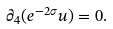Convert formula to latex. <formula><loc_0><loc_0><loc_500><loc_500>\partial _ { 4 } ( e ^ { - 2 \sigma } u ) = 0 .</formula> 